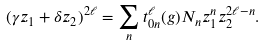Convert formula to latex. <formula><loc_0><loc_0><loc_500><loc_500>( \gamma z _ { 1 } + \delta z _ { 2 } ) ^ { 2 \ell } = \sum _ { n } t _ { 0 n } ^ { \ell } ( g ) N _ { n } z _ { 1 } ^ { n } z _ { 2 } ^ { 2 \ell - n } .</formula> 